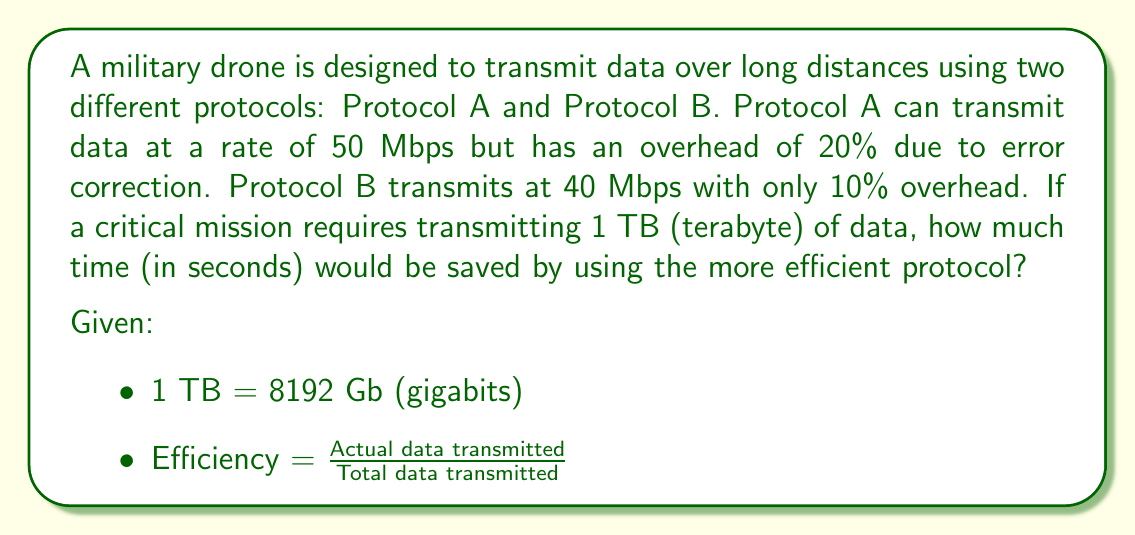Give your solution to this math problem. To solve this problem, we need to calculate the effective transmission rate for each protocol and then determine which one is more efficient.

1. Calculate effective transmission rates:

   Protocol A:
   $$\text{Effective rate}_A = 50 \text{ Mbps} \times (1 - 0.20) = 40 \text{ Mbps}$$

   Protocol B:
   $$\text{Effective rate}_B = 40 \text{ Mbps} \times (1 - 0.10) = 36 \text{ Mbps}$$

2. Calculate time required for each protocol to transmit 1 TB:

   Time for Protocol A:
   $$\text{Time}_A = \frac{8192 \text{ Gb}}{40 \text{ Gbps}} = 204.8 \text{ seconds}$$

   Time for Protocol B:
   $$\text{Time}_B = \frac{8192 \text{ Gb}}{36 \text{ Gbps}} = 227.5556 \text{ seconds}$$

3. Calculate the time difference:

   $$\text{Time saved} = \text{Time}_B - \text{Time}_A = 227.5556 - 204.8 = 22.7556 \text{ seconds}$$

Therefore, using Protocol A (the more efficient protocol) would save approximately 22.7556 seconds in transmitting 1 TB of data.
Answer: 22.7556 seconds 